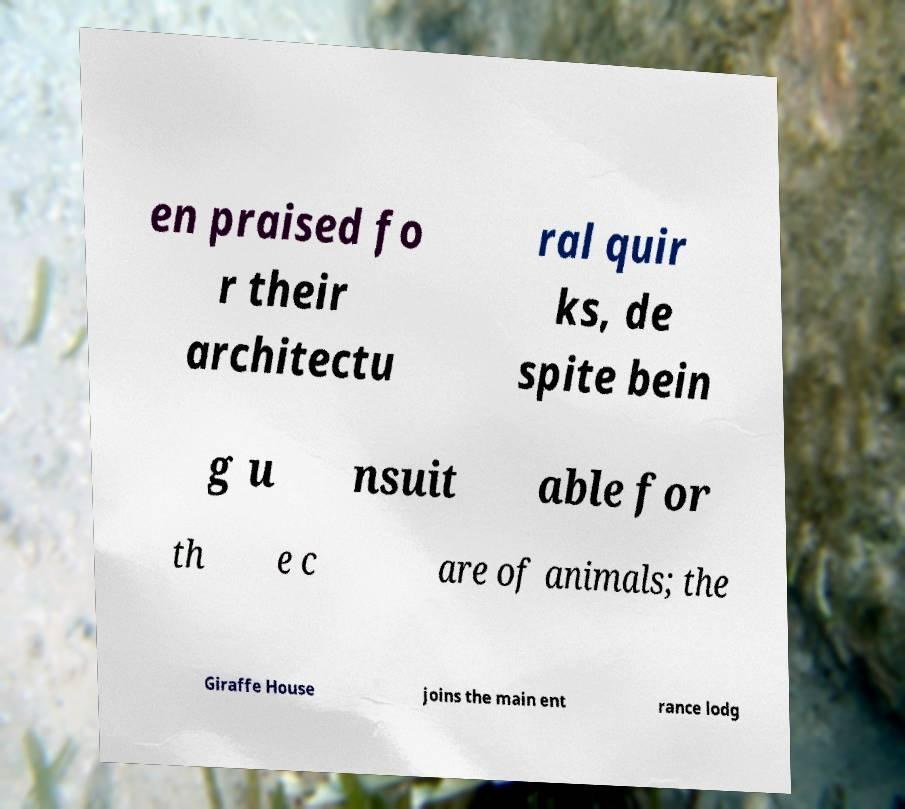Could you extract and type out the text from this image? en praised fo r their architectu ral quir ks, de spite bein g u nsuit able for th e c are of animals; the Giraffe House joins the main ent rance lodg 